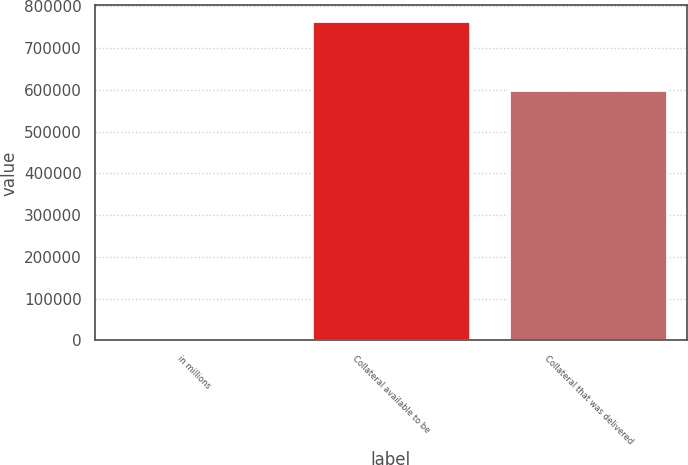Convert chart. <chart><loc_0><loc_0><loc_500><loc_500><bar_chart><fcel>in millions<fcel>Collateral available to be<fcel>Collateral that was delivered<nl><fcel>2017<fcel>763984<fcel>599565<nl></chart> 